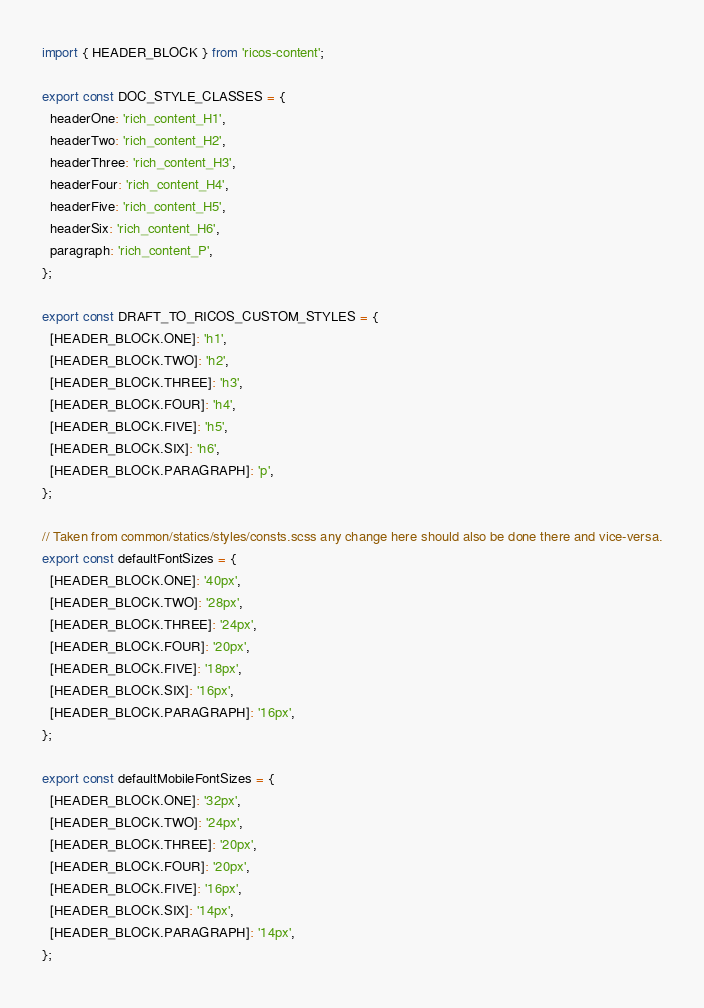Convert code to text. <code><loc_0><loc_0><loc_500><loc_500><_TypeScript_>import { HEADER_BLOCK } from 'ricos-content';

export const DOC_STYLE_CLASSES = {
  headerOne: 'rich_content_H1',
  headerTwo: 'rich_content_H2',
  headerThree: 'rich_content_H3',
  headerFour: 'rich_content_H4',
  headerFive: 'rich_content_H5',
  headerSix: 'rich_content_H6',
  paragraph: 'rich_content_P',
};

export const DRAFT_TO_RICOS_CUSTOM_STYLES = {
  [HEADER_BLOCK.ONE]: 'h1',
  [HEADER_BLOCK.TWO]: 'h2',
  [HEADER_BLOCK.THREE]: 'h3',
  [HEADER_BLOCK.FOUR]: 'h4',
  [HEADER_BLOCK.FIVE]: 'h5',
  [HEADER_BLOCK.SIX]: 'h6',
  [HEADER_BLOCK.PARAGRAPH]: 'p',
};

// Taken from common/statics/styles/consts.scss any change here should also be done there and vice-versa.
export const defaultFontSizes = {
  [HEADER_BLOCK.ONE]: '40px',
  [HEADER_BLOCK.TWO]: '28px',
  [HEADER_BLOCK.THREE]: '24px',
  [HEADER_BLOCK.FOUR]: '20px',
  [HEADER_BLOCK.FIVE]: '18px',
  [HEADER_BLOCK.SIX]: '16px',
  [HEADER_BLOCK.PARAGRAPH]: '16px',
};

export const defaultMobileFontSizes = {
  [HEADER_BLOCK.ONE]: '32px',
  [HEADER_BLOCK.TWO]: '24px',
  [HEADER_BLOCK.THREE]: '20px',
  [HEADER_BLOCK.FOUR]: '20px',
  [HEADER_BLOCK.FIVE]: '16px',
  [HEADER_BLOCK.SIX]: '14px',
  [HEADER_BLOCK.PARAGRAPH]: '14px',
};
</code> 